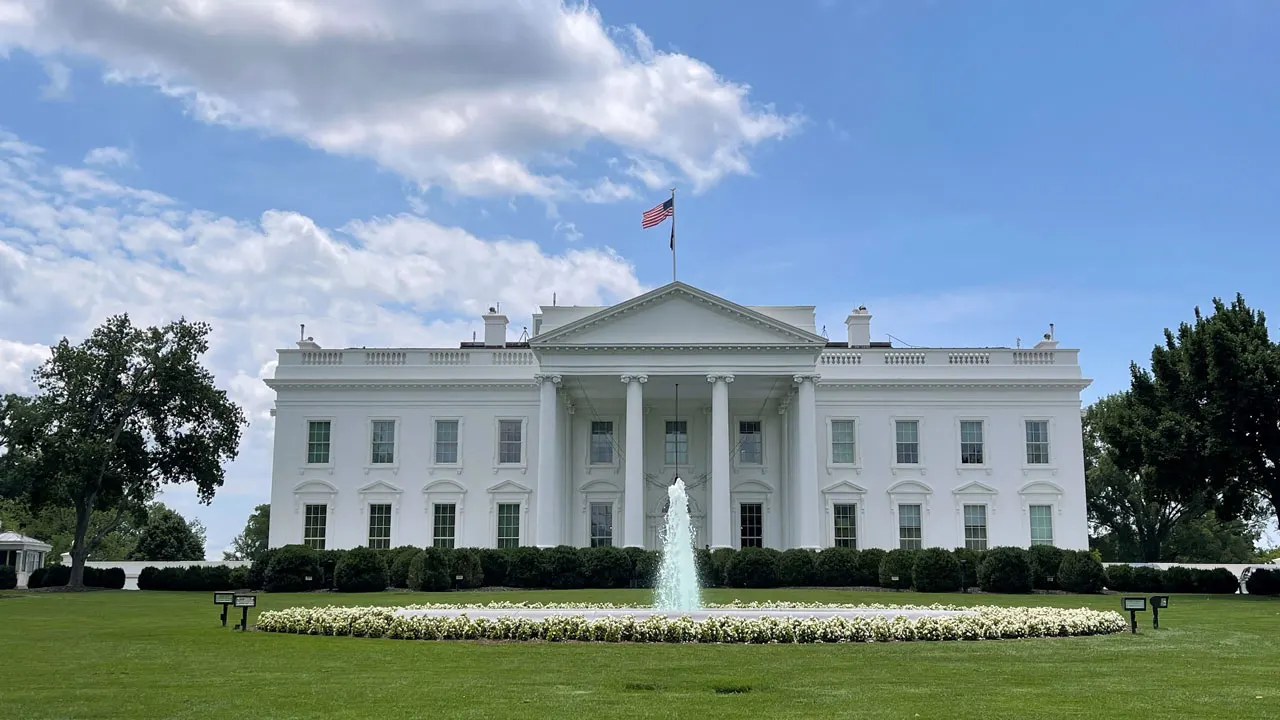Can you elaborate on the elements of the picture provided? The photograph features the stately White House, a symbol of the American presidency, ensconced amidst the meticulously manicured lawns. The Neoclassical architecture of the White House, with its prominent Ionic columns and pediment, reflects the ideals of democracy and the influence of ancient Greek and Roman design. The pristine white exterior is a nod to its namesake and offers a stark contrast to the lush greenery that surrounds it. At the heart of the North Lawn, the water of the fountain leaps skyward, mirroring the fluttering American flag that crowns the building, a proud emblem of the nation's history and government. The composition of the image, with clear skies above and an uninterrupted view of this architectural marvel, invites contemplation of the White House's role as a home to numerous presidents and as a venue for momentous decisions that have shaped global history. 